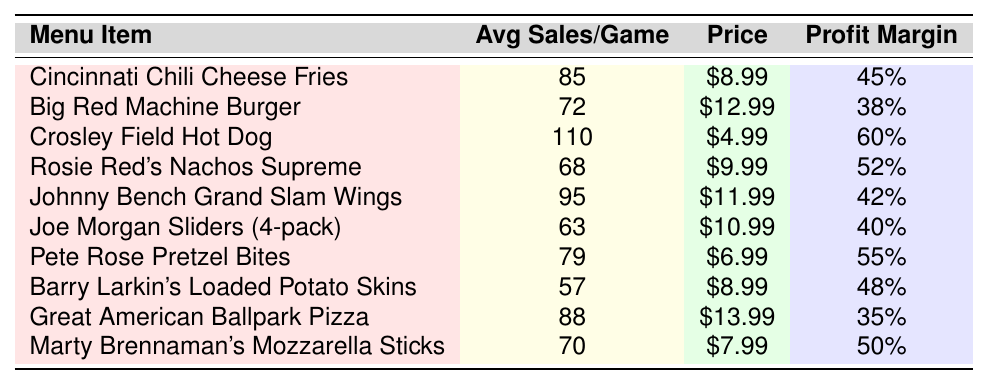What is the top-selling menu item during Reds game nights? The table lists the menu items along with their average sales per game. The item with the highest average sales is the Crosley Field Hot Dog, with 110 sales.
Answer: Crosley Field Hot Dog How many average sales did the Great American Ballpark Pizza achieve? The table shows that the Great American Ballpark Pizza had an average of 88 sales per game.
Answer: 88 Which menu item has the highest profit margin? The table indicates that the Crosley Field Hot Dog has the highest profit margin at 60%.
Answer: Crosley Field Hot Dog What is the combined average sales of the Big Red Machine Burger and Johnny Bench Grand Slam Wings? Adding the average sales of the Big Red Machine Burger (72) and Johnny Bench Grand Slam Wings (95) gives 72 + 95 = 167.
Answer: 167 Is the profit margin of Rosie Red's Nachos Supreme higher than that of Joe Morgan Sliders? Rosie Red's Nachos Supreme has a profit margin of 52%, while Joe Morgan Sliders has a profit margin of 40%. Since 52% is greater than 40%, the statement is true.
Answer: Yes What is the average price of the top three selling menu items? The top three selling items are the Crosley Field Hot Dog ($4.99), Johnny Bench Grand Slam Wings ($11.99), and Cincinnati Chili Cheese Fries ($8.99). Adding their prices gives $4.99 + $11.99 + $8.99 = $25.97. Dividing by 3 gives an average price of $25.97 / 3 ≈ $8.66.
Answer: Approximately $8.66 Which menu items have an average sales of over 80? The items with more than 80 average sales are Crosley Field Hot Dog (110), Johnny Bench Grand Slam Wings (95), Cincinnati Chili Cheese Fries (85), and Great American Ballpark Pizza (88).
Answer: Crosley Field Hot Dog, Johnny Bench Grand Slam Wings, Cincinnati Chili Cheese Fries, Great American Ballpark Pizza What is the profit margin difference between the Big Red Machine Burger and the Great American Ballpark Pizza? The Big Red Machine Burger has a profit margin of 38%, while the Great American Ballpark Pizza has a profit margin of 35%. The difference is 38% - 35% = 3%.
Answer: 3% How much profit, on average, can be expected from selling 100 Crosley Field Hot Dogs? The price of a Crosley Field Hot Dog is $4.99 with a profit margin of 60%. The profit per hot dog is $4.99 * 60% = $2.99. Thus, for 100 hot dogs, the profit is 100 * $2.99 = $299.
Answer: $299 Which item sold the least on average during game nights? The table shows that Barry Larkin's Loaded Potato Skins had the lowest average sales with 57 per game.
Answer: Barry Larkin's Loaded Potato Skins 